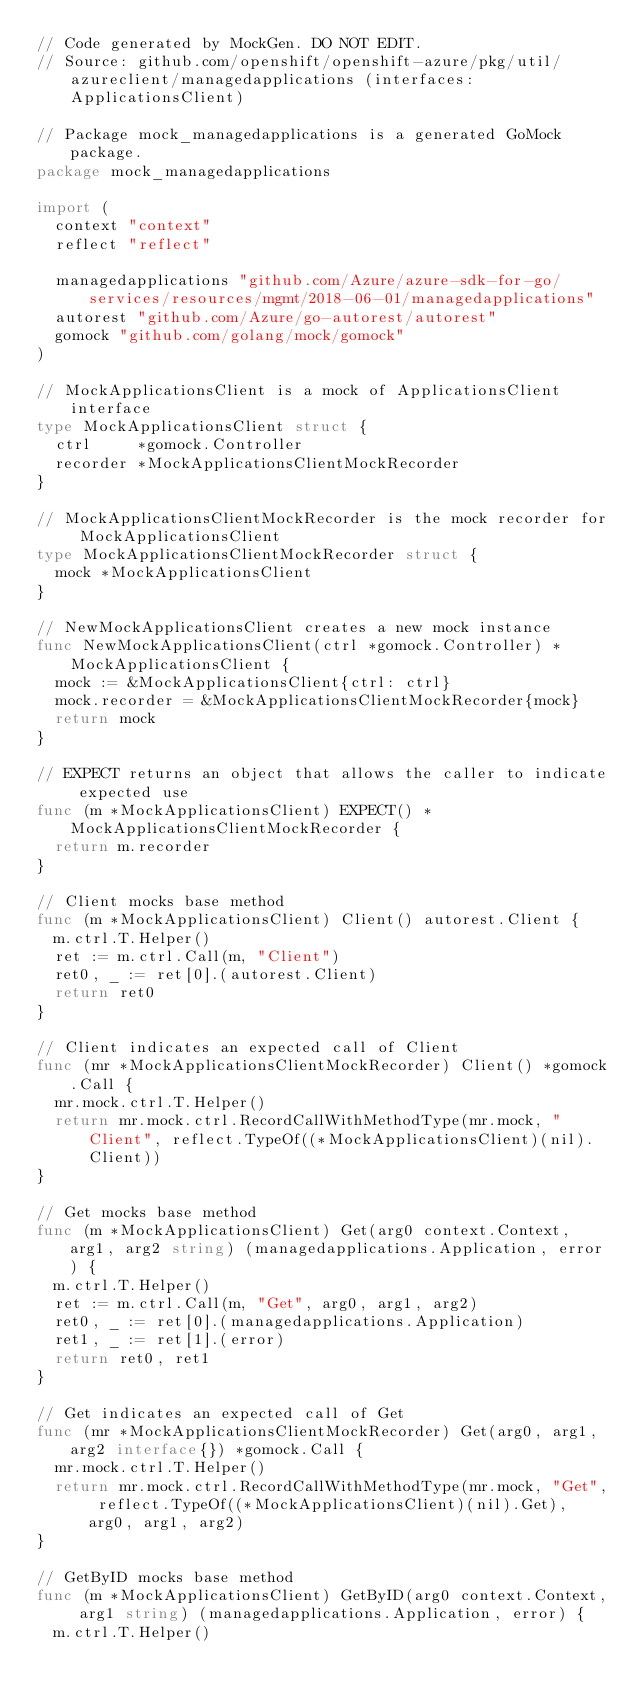Convert code to text. <code><loc_0><loc_0><loc_500><loc_500><_Go_>// Code generated by MockGen. DO NOT EDIT.
// Source: github.com/openshift/openshift-azure/pkg/util/azureclient/managedapplications (interfaces: ApplicationsClient)

// Package mock_managedapplications is a generated GoMock package.
package mock_managedapplications

import (
	context "context"
	reflect "reflect"

	managedapplications "github.com/Azure/azure-sdk-for-go/services/resources/mgmt/2018-06-01/managedapplications"
	autorest "github.com/Azure/go-autorest/autorest"
	gomock "github.com/golang/mock/gomock"
)

// MockApplicationsClient is a mock of ApplicationsClient interface
type MockApplicationsClient struct {
	ctrl     *gomock.Controller
	recorder *MockApplicationsClientMockRecorder
}

// MockApplicationsClientMockRecorder is the mock recorder for MockApplicationsClient
type MockApplicationsClientMockRecorder struct {
	mock *MockApplicationsClient
}

// NewMockApplicationsClient creates a new mock instance
func NewMockApplicationsClient(ctrl *gomock.Controller) *MockApplicationsClient {
	mock := &MockApplicationsClient{ctrl: ctrl}
	mock.recorder = &MockApplicationsClientMockRecorder{mock}
	return mock
}

// EXPECT returns an object that allows the caller to indicate expected use
func (m *MockApplicationsClient) EXPECT() *MockApplicationsClientMockRecorder {
	return m.recorder
}

// Client mocks base method
func (m *MockApplicationsClient) Client() autorest.Client {
	m.ctrl.T.Helper()
	ret := m.ctrl.Call(m, "Client")
	ret0, _ := ret[0].(autorest.Client)
	return ret0
}

// Client indicates an expected call of Client
func (mr *MockApplicationsClientMockRecorder) Client() *gomock.Call {
	mr.mock.ctrl.T.Helper()
	return mr.mock.ctrl.RecordCallWithMethodType(mr.mock, "Client", reflect.TypeOf((*MockApplicationsClient)(nil).Client))
}

// Get mocks base method
func (m *MockApplicationsClient) Get(arg0 context.Context, arg1, arg2 string) (managedapplications.Application, error) {
	m.ctrl.T.Helper()
	ret := m.ctrl.Call(m, "Get", arg0, arg1, arg2)
	ret0, _ := ret[0].(managedapplications.Application)
	ret1, _ := ret[1].(error)
	return ret0, ret1
}

// Get indicates an expected call of Get
func (mr *MockApplicationsClientMockRecorder) Get(arg0, arg1, arg2 interface{}) *gomock.Call {
	mr.mock.ctrl.T.Helper()
	return mr.mock.ctrl.RecordCallWithMethodType(mr.mock, "Get", reflect.TypeOf((*MockApplicationsClient)(nil).Get), arg0, arg1, arg2)
}

// GetByID mocks base method
func (m *MockApplicationsClient) GetByID(arg0 context.Context, arg1 string) (managedapplications.Application, error) {
	m.ctrl.T.Helper()</code> 